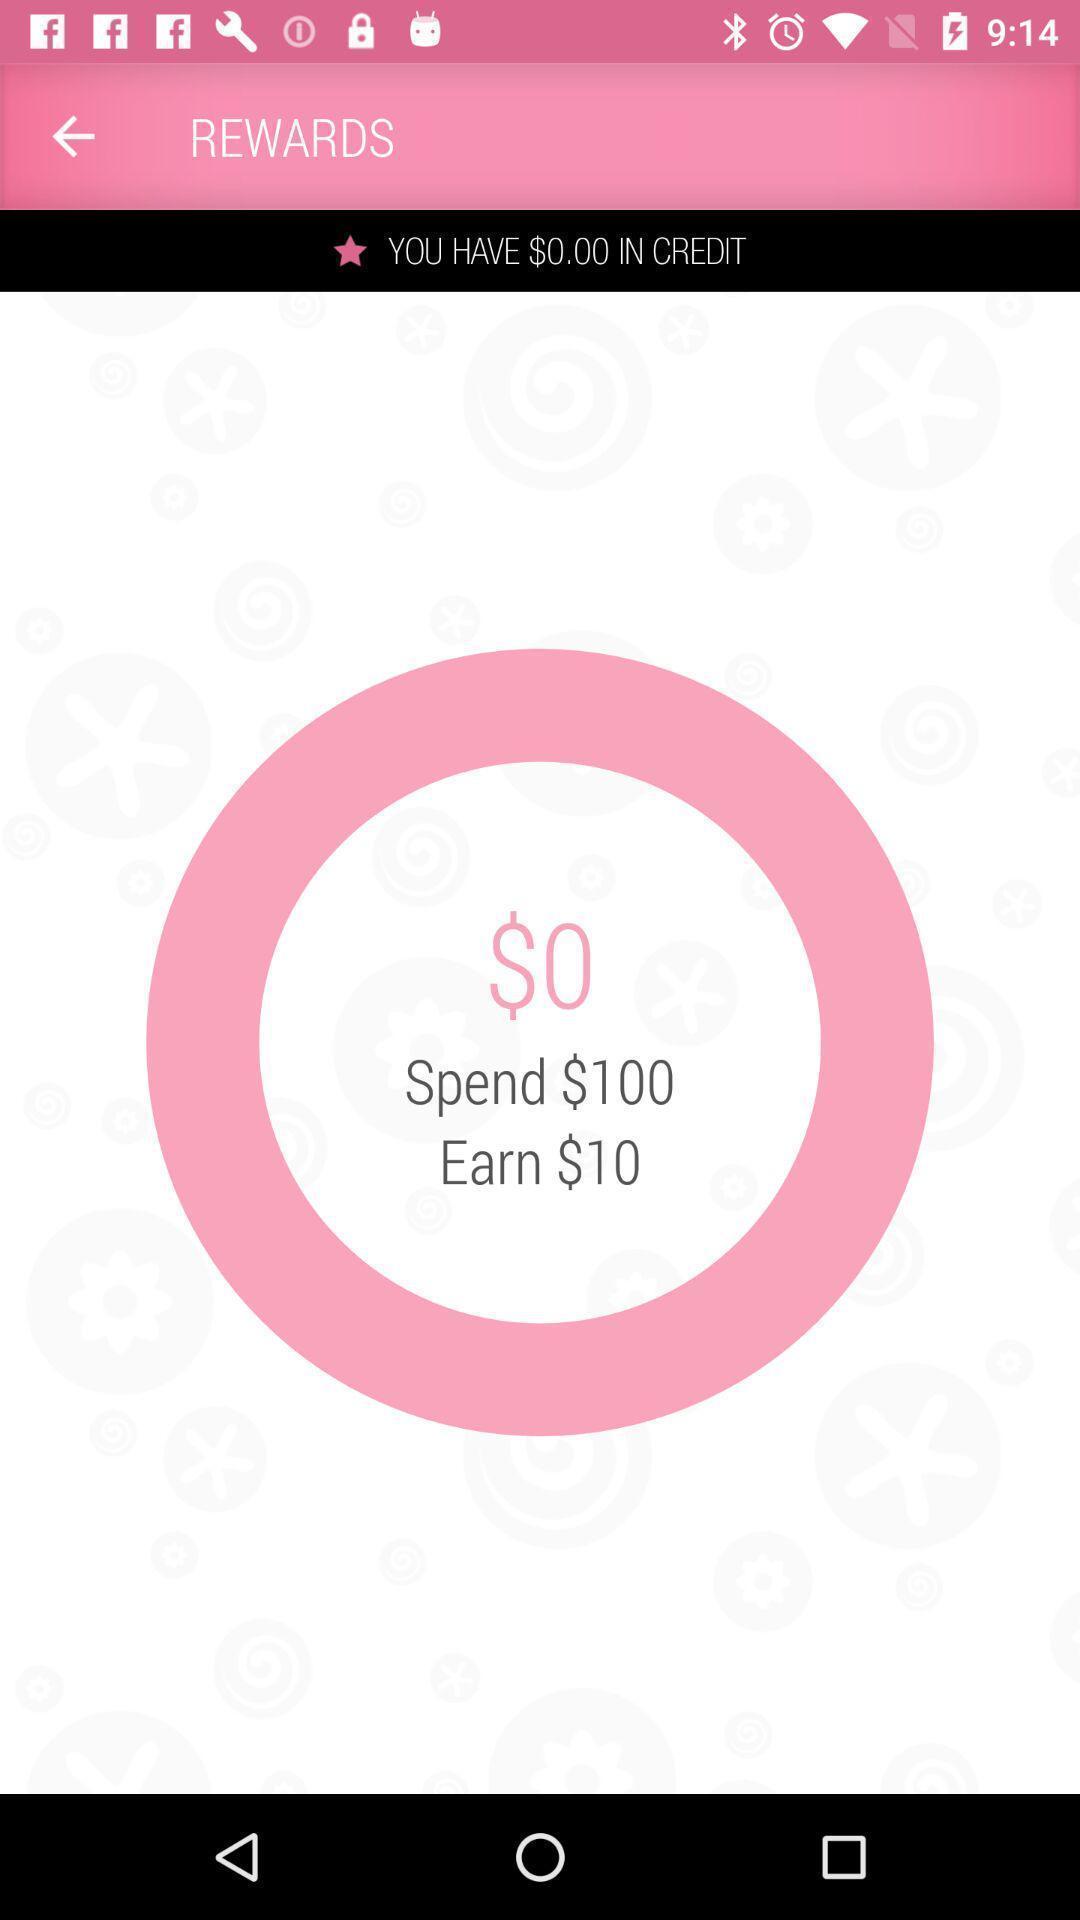What can you discern from this picture? Page showing the rewards section. 